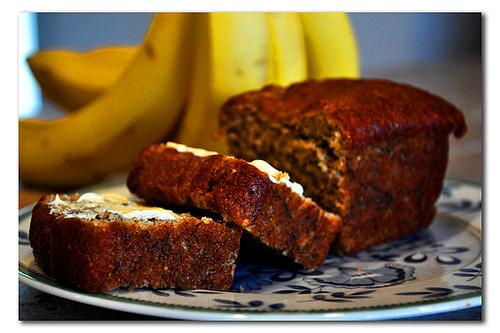What kind of bread is this?
Short answer required. Banana. Is there a pattern on the plate under the bread?
Be succinct. Yes. What fruit is in the back?
Concise answer only. Banana. 